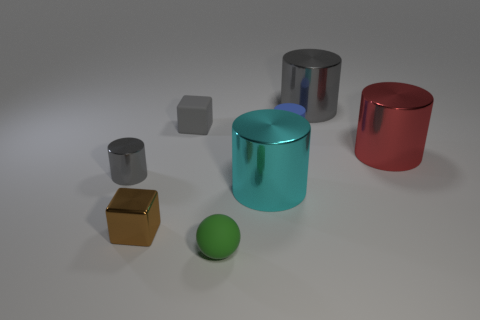Does the small cylinder left of the big cyan cylinder have the same material as the ball?
Offer a very short reply. No. How many other things are there of the same material as the large red object?
Provide a short and direct response. 4. There is a gray cylinder that is the same size as the green ball; what material is it?
Offer a terse response. Metal. There is a brown shiny thing in front of the red object; is its shape the same as the gray shiny object that is to the left of the gray rubber cube?
Provide a succinct answer. No. There is a green matte object that is the same size as the gray block; what is its shape?
Give a very brief answer. Sphere. Does the small cube that is in front of the gray rubber object have the same material as the tiny gray object that is behind the red shiny cylinder?
Keep it short and to the point. No. There is a cube that is behind the big red thing; are there any cubes that are to the left of it?
Ensure brevity in your answer.  Yes. What is the color of the tiny cylinder that is made of the same material as the brown thing?
Provide a short and direct response. Gray. Are there more small blue cylinders than large red metallic cubes?
Provide a succinct answer. Yes. What number of objects are either metallic objects that are on the right side of the ball or big purple matte objects?
Offer a terse response. 3. 